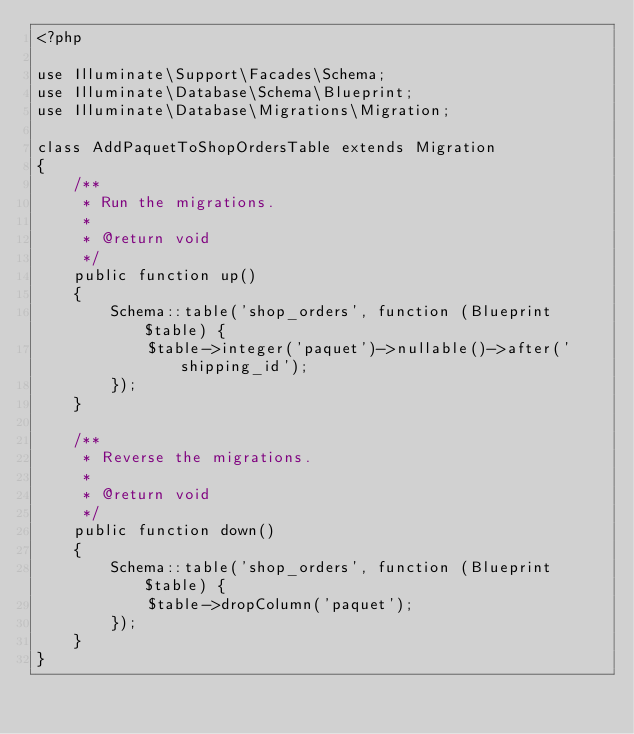Convert code to text. <code><loc_0><loc_0><loc_500><loc_500><_PHP_><?php

use Illuminate\Support\Facades\Schema;
use Illuminate\Database\Schema\Blueprint;
use Illuminate\Database\Migrations\Migration;

class AddPaquetToShopOrdersTable extends Migration
{
    /**
     * Run the migrations.
     *
     * @return void
     */
    public function up()
    {
        Schema::table('shop_orders', function (Blueprint $table) {
            $table->integer('paquet')->nullable()->after('shipping_id');
        });
    }

    /**
     * Reverse the migrations.
     *
     * @return void
     */
    public function down()
    {
        Schema::table('shop_orders', function (Blueprint $table) {
            $table->dropColumn('paquet');
        });
    }
}
</code> 